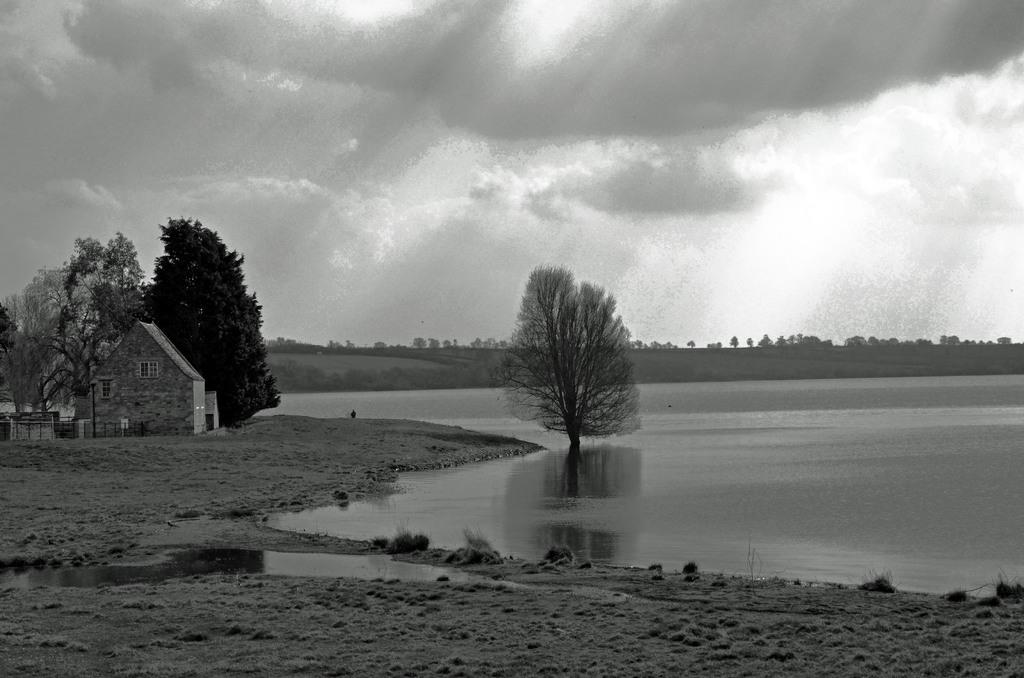What is the color scheme of the image? The image is black and white. What can be seen on the right side of the image? There is water on the right side of the image. What is located on the left side of the image? There are trees and a building with windows on the left side of the image. What is visible in the background of the image? The sky is visible in the background of the image. What can be observed in the sky? Clouds are present in the sky. What type of van can be seen parked near the trees in the image? There is no van present in the image; it features water, trees, a building, and clouds. What kind of bread is being used to make a sandwich in the image? There is no bread or sandwich-making activity present in the image. 